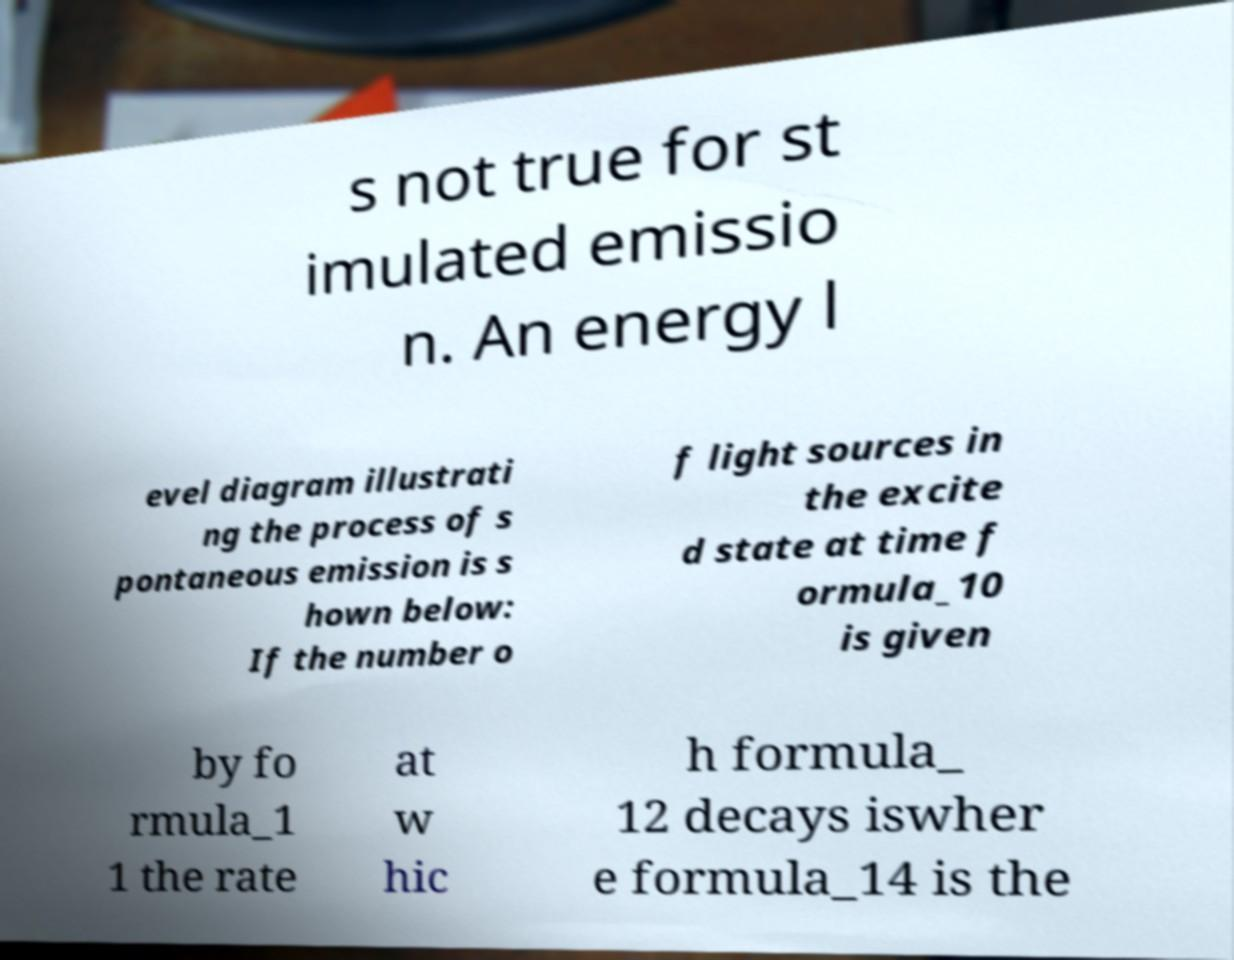Could you extract and type out the text from this image? s not true for st imulated emissio n. An energy l evel diagram illustrati ng the process of s pontaneous emission is s hown below: If the number o f light sources in the excite d state at time f ormula_10 is given by fo rmula_1 1 the rate at w hic h formula_ 12 decays iswher e formula_14 is the 